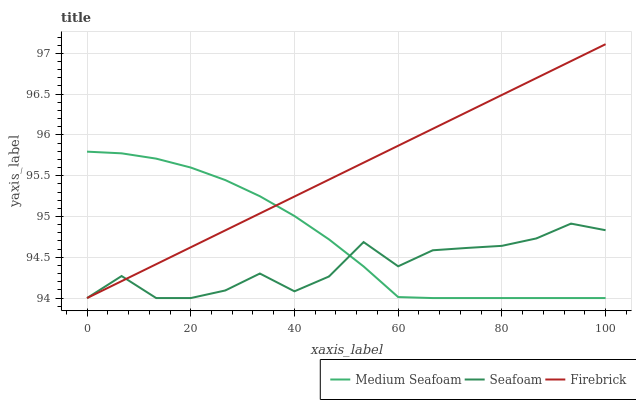Does Seafoam have the minimum area under the curve?
Answer yes or no. Yes. Does Firebrick have the maximum area under the curve?
Answer yes or no. Yes. Does Medium Seafoam have the minimum area under the curve?
Answer yes or no. No. Does Medium Seafoam have the maximum area under the curve?
Answer yes or no. No. Is Firebrick the smoothest?
Answer yes or no. Yes. Is Seafoam the roughest?
Answer yes or no. Yes. Is Medium Seafoam the smoothest?
Answer yes or no. No. Is Medium Seafoam the roughest?
Answer yes or no. No. Does Firebrick have the lowest value?
Answer yes or no. Yes. Does Firebrick have the highest value?
Answer yes or no. Yes. Does Medium Seafoam have the highest value?
Answer yes or no. No. Does Firebrick intersect Medium Seafoam?
Answer yes or no. Yes. Is Firebrick less than Medium Seafoam?
Answer yes or no. No. Is Firebrick greater than Medium Seafoam?
Answer yes or no. No. 